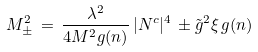Convert formula to latex. <formula><loc_0><loc_0><loc_500><loc_500>M _ { \pm } ^ { 2 } \, = \, \frac { \lambda ^ { 2 } } { 4 M ^ { 2 } g ( n ) } \, | N ^ { c } | ^ { 4 } \, \pm \tilde { g } ^ { 2 } \xi \, g ( n ) \,</formula> 